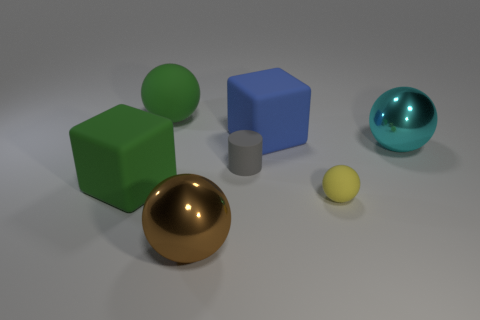What is the size of the brown thing that is the same shape as the cyan object?
Make the answer very short. Large. What is the material of the big object that is both to the right of the large brown shiny object and left of the yellow rubber object?
Your answer should be very brief. Rubber. What color is the other object that is the same shape as the blue rubber thing?
Provide a short and direct response. Green. What color is the matte sphere that is the same size as the brown object?
Keep it short and to the point. Green. Are there more rubber balls behind the small gray rubber cylinder than large brown metallic spheres that are behind the cyan shiny ball?
Your response must be concise. Yes. The matte object that is the same color as the large rubber ball is what size?
Your answer should be compact. Large. What number of other things are the same size as the gray rubber cylinder?
Your response must be concise. 1. Are the sphere right of the small yellow ball and the tiny gray object made of the same material?
Give a very brief answer. No. How many other objects are the same color as the big rubber ball?
Keep it short and to the point. 1. How many other things are there of the same shape as the blue rubber object?
Your response must be concise. 1. 